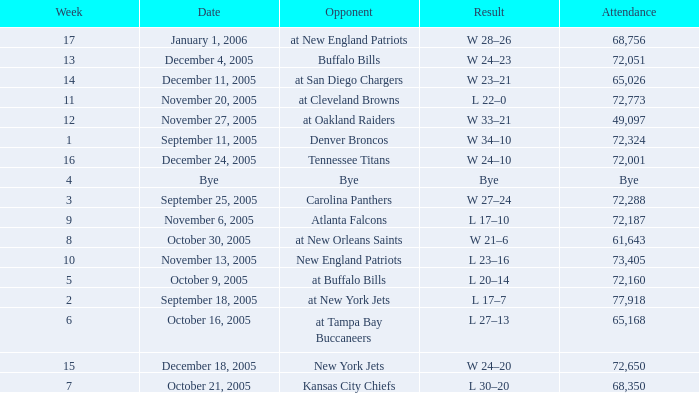Who was the Opponent on November 27, 2005? At oakland raiders. 